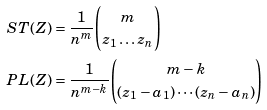Convert formula to latex. <formula><loc_0><loc_0><loc_500><loc_500>S T ( Z ) & = \frac { 1 } { n ^ { m } } \binom { m } { z _ { 1 } \dots z _ { n } } \\ P L ( Z ) & = \frac { 1 } { n ^ { m - k } } \binom { m - k } { ( z _ { 1 } - a _ { 1 } ) \cdots ( z _ { n } - a _ { n } ) }</formula> 